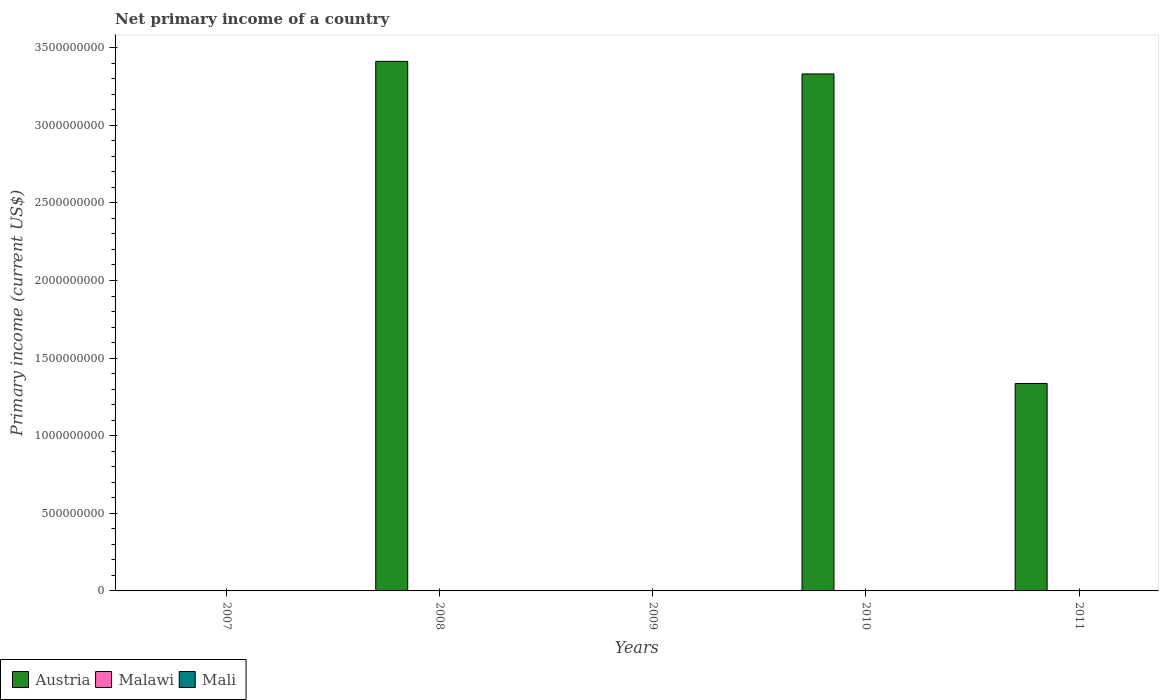How many different coloured bars are there?
Your answer should be very brief. 1. How many bars are there on the 5th tick from the left?
Keep it short and to the point. 1. How many bars are there on the 2nd tick from the right?
Give a very brief answer. 1. What is the primary income in Malawi in 2008?
Provide a succinct answer. 0. Across all years, what is the minimum primary income in Malawi?
Give a very brief answer. 0. In which year was the primary income in Austria maximum?
Make the answer very short. 2008. What is the total primary income in Austria in the graph?
Keep it short and to the point. 8.08e+09. What is the difference between the primary income in Austria in 2010 and that in 2011?
Make the answer very short. 1.99e+09. What is the difference between the primary income in Austria in 2010 and the primary income in Malawi in 2009?
Provide a succinct answer. 3.33e+09. What is the average primary income in Austria per year?
Ensure brevity in your answer.  1.62e+09. In how many years, is the primary income in Malawi greater than 2200000000 US$?
Offer a very short reply. 0. What is the ratio of the primary income in Austria in 2008 to that in 2011?
Your response must be concise. 2.55. What is the difference between the highest and the second highest primary income in Austria?
Provide a succinct answer. 8.11e+07. What is the difference between the highest and the lowest primary income in Austria?
Keep it short and to the point. 3.41e+09. How many years are there in the graph?
Your answer should be compact. 5. Does the graph contain grids?
Provide a succinct answer. No. What is the title of the graph?
Offer a terse response. Net primary income of a country. What is the label or title of the X-axis?
Keep it short and to the point. Years. What is the label or title of the Y-axis?
Your response must be concise. Primary income (current US$). What is the Primary income (current US$) of Austria in 2007?
Ensure brevity in your answer.  0. What is the Primary income (current US$) in Malawi in 2007?
Ensure brevity in your answer.  0. What is the Primary income (current US$) of Mali in 2007?
Your answer should be compact. 0. What is the Primary income (current US$) of Austria in 2008?
Provide a short and direct response. 3.41e+09. What is the Primary income (current US$) in Malawi in 2008?
Your answer should be very brief. 0. What is the Primary income (current US$) in Mali in 2009?
Provide a succinct answer. 0. What is the Primary income (current US$) of Austria in 2010?
Your answer should be compact. 3.33e+09. What is the Primary income (current US$) in Mali in 2010?
Provide a short and direct response. 0. What is the Primary income (current US$) of Austria in 2011?
Offer a very short reply. 1.34e+09. What is the Primary income (current US$) in Malawi in 2011?
Give a very brief answer. 0. What is the Primary income (current US$) in Mali in 2011?
Your answer should be very brief. 0. Across all years, what is the maximum Primary income (current US$) in Austria?
Your answer should be compact. 3.41e+09. What is the total Primary income (current US$) in Austria in the graph?
Make the answer very short. 8.08e+09. What is the difference between the Primary income (current US$) in Austria in 2008 and that in 2010?
Your response must be concise. 8.11e+07. What is the difference between the Primary income (current US$) in Austria in 2008 and that in 2011?
Provide a succinct answer. 2.08e+09. What is the difference between the Primary income (current US$) of Austria in 2010 and that in 2011?
Your answer should be compact. 1.99e+09. What is the average Primary income (current US$) of Austria per year?
Give a very brief answer. 1.62e+09. What is the average Primary income (current US$) of Malawi per year?
Provide a succinct answer. 0. What is the ratio of the Primary income (current US$) in Austria in 2008 to that in 2010?
Ensure brevity in your answer.  1.02. What is the ratio of the Primary income (current US$) of Austria in 2008 to that in 2011?
Make the answer very short. 2.55. What is the ratio of the Primary income (current US$) in Austria in 2010 to that in 2011?
Provide a succinct answer. 2.49. What is the difference between the highest and the second highest Primary income (current US$) in Austria?
Provide a succinct answer. 8.11e+07. What is the difference between the highest and the lowest Primary income (current US$) of Austria?
Make the answer very short. 3.41e+09. 